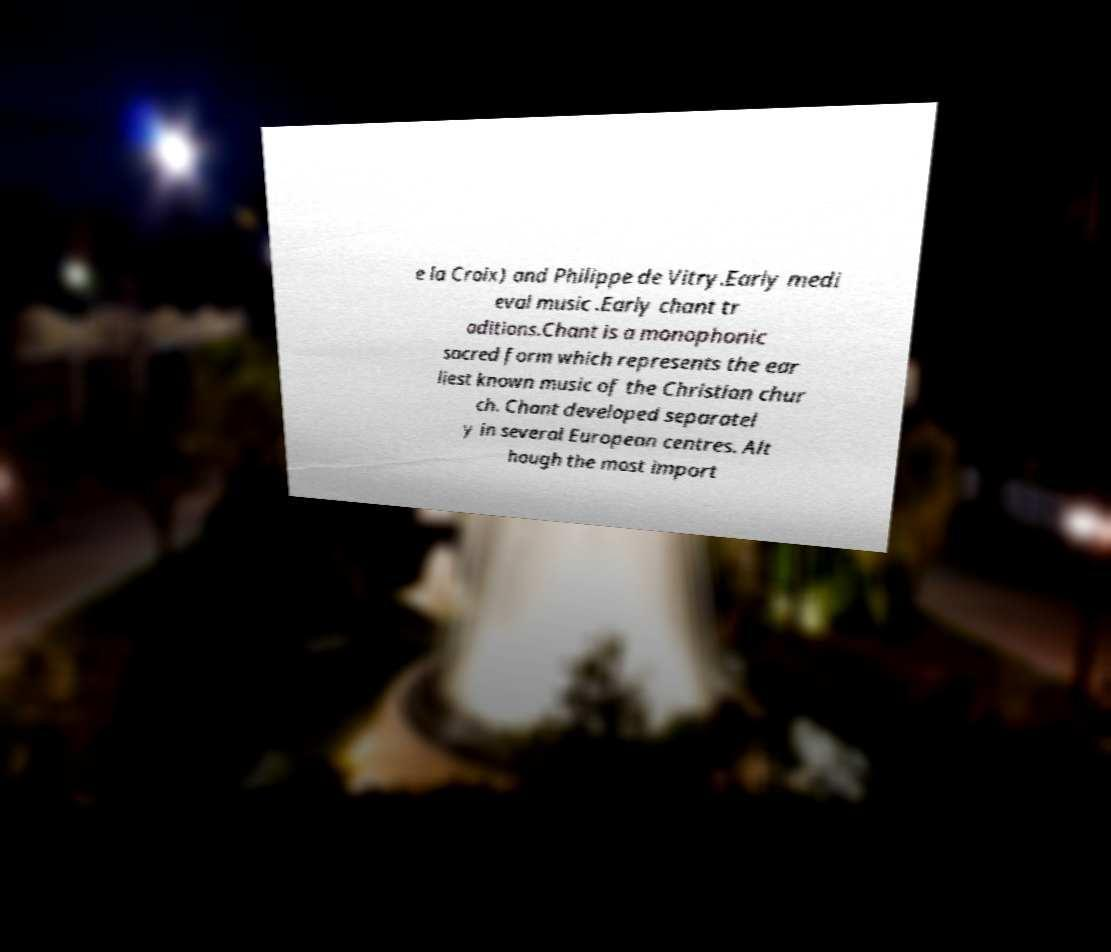Please identify and transcribe the text found in this image. e la Croix) and Philippe de Vitry.Early medi eval music .Early chant tr aditions.Chant is a monophonic sacred form which represents the ear liest known music of the Christian chur ch. Chant developed separatel y in several European centres. Alt hough the most import 